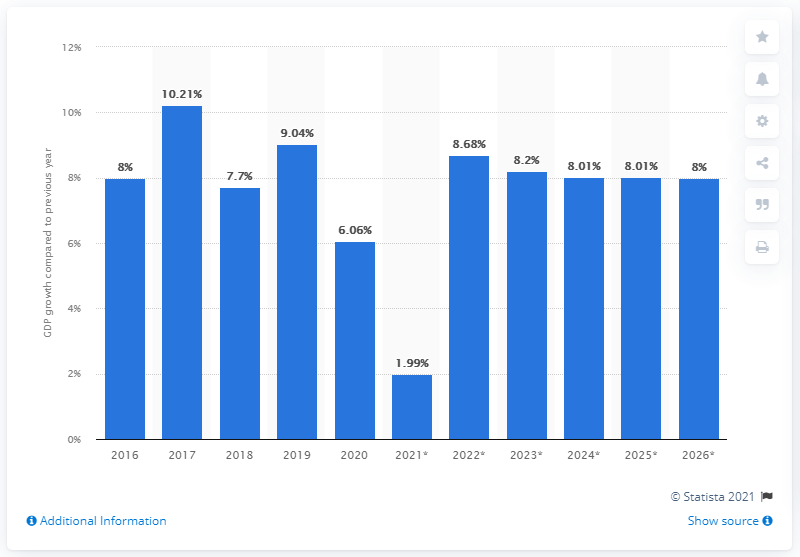Point out several critical features in this image. According to recent estimates, Ethiopia's real GDP grew by 9.04% in 2019. 